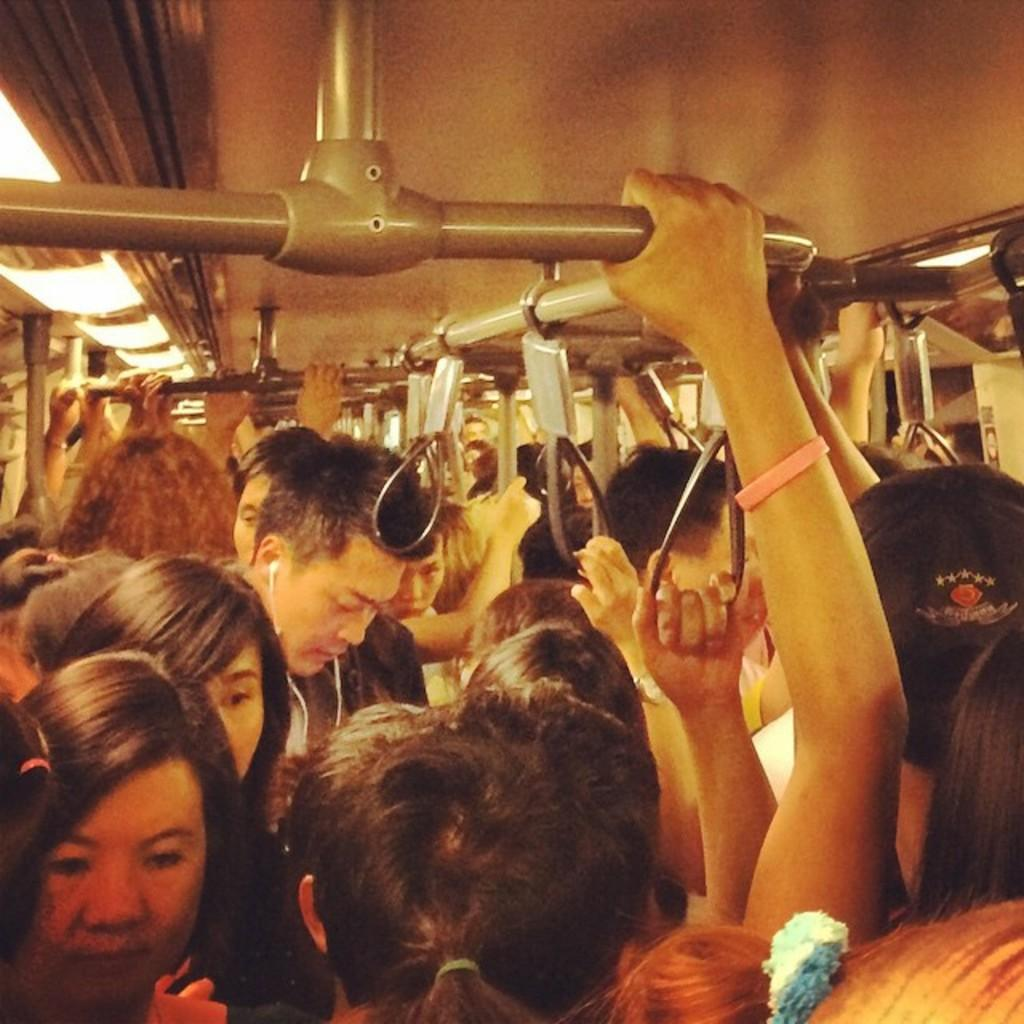How many people are in the image? There are many people in the image. What are the people doing in the image? The people are standing in a bus. What objects are the people holding in the image? The people are holding hangers and poles from the top. Can you hear the goldfish laughing in the image? There are no goldfish or sounds in the image, so it's not possible to determine if they are laughing. 